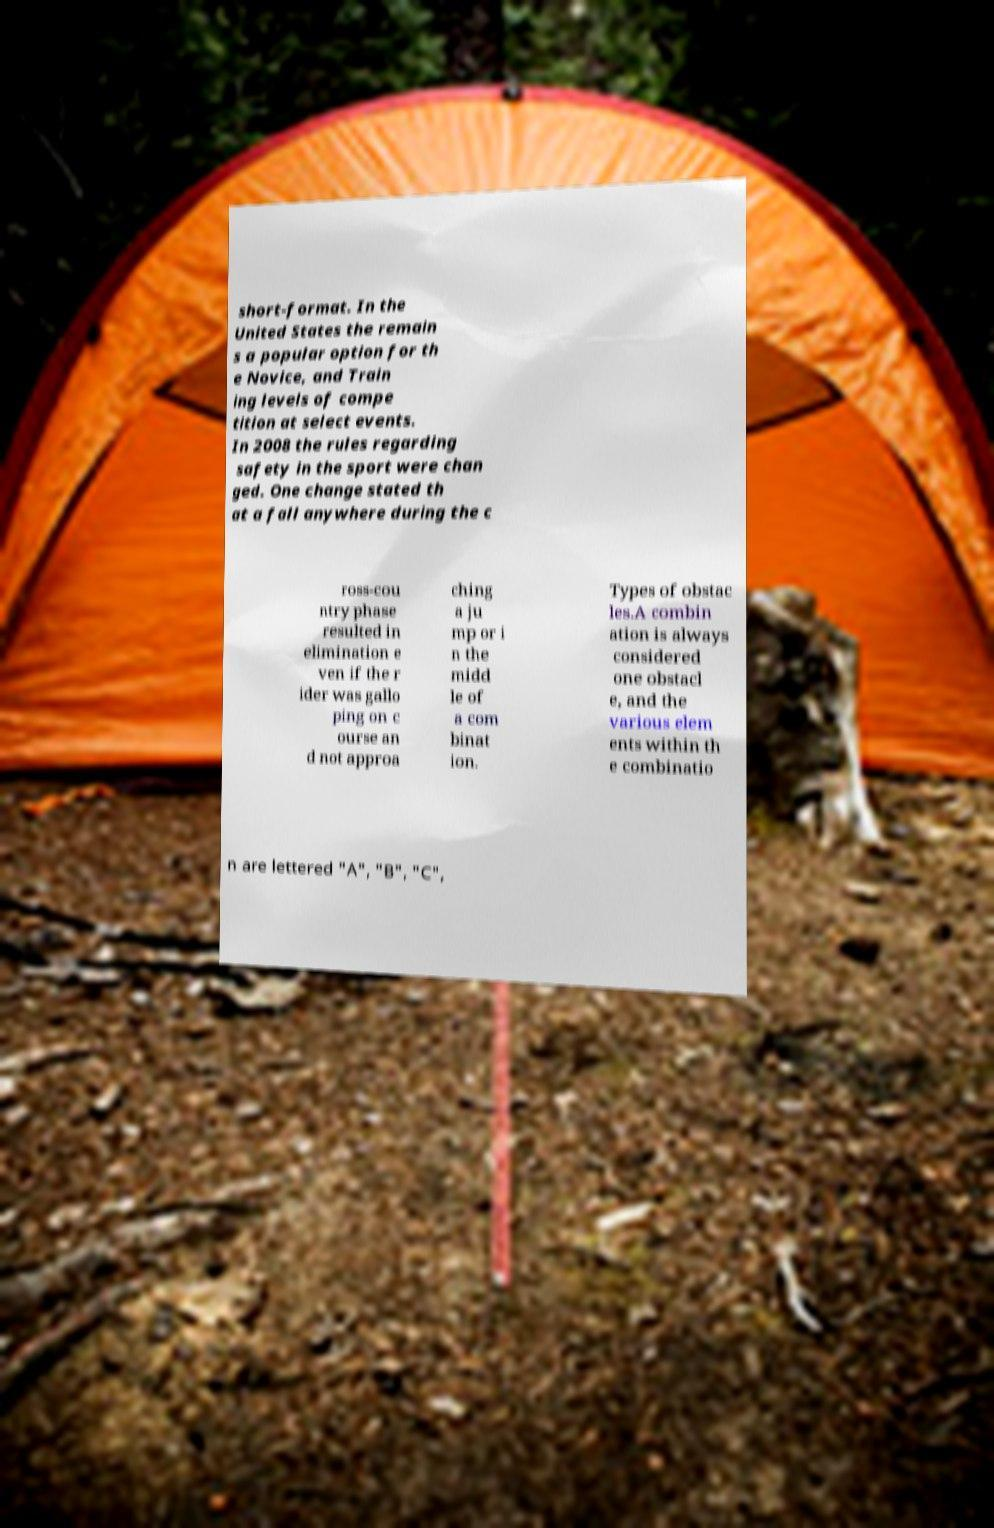There's text embedded in this image that I need extracted. Can you transcribe it verbatim? short-format. In the United States the remain s a popular option for th e Novice, and Train ing levels of compe tition at select events. In 2008 the rules regarding safety in the sport were chan ged. One change stated th at a fall anywhere during the c ross-cou ntry phase resulted in elimination e ven if the r ider was gallo ping on c ourse an d not approa ching a ju mp or i n the midd le of a com binat ion. Types of obstac les.A combin ation is always considered one obstacl e, and the various elem ents within th e combinatio n are lettered "A", "B", "C", 